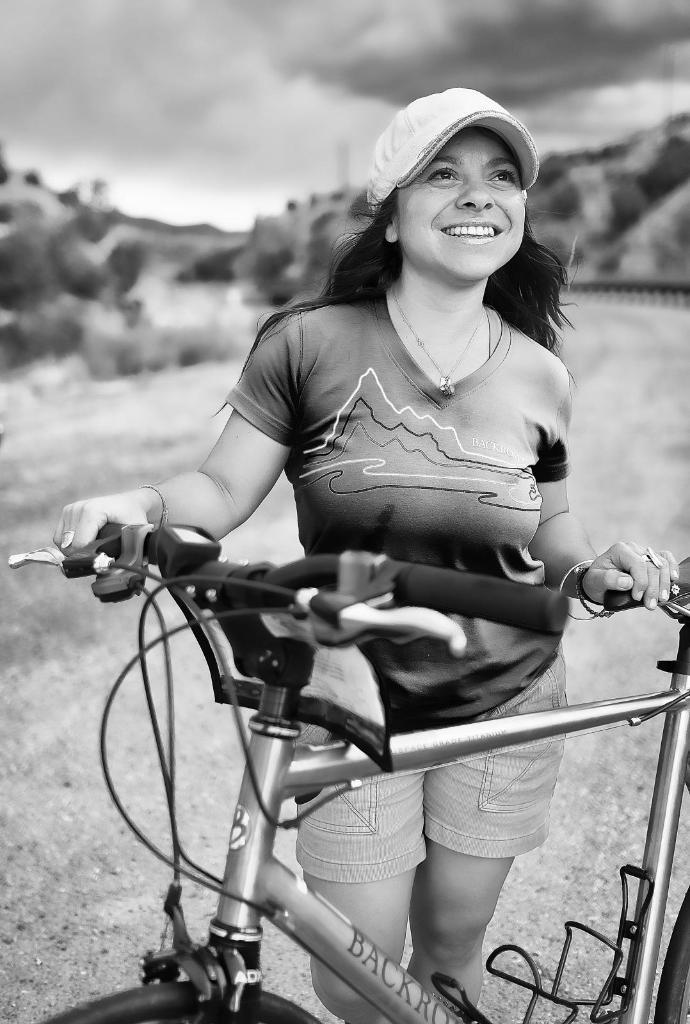What is the color scheme of the image? The image is black and white. Who is in the foreground of the image? There is a woman in the foreground of the image. What is the woman doing or holding in the image? The woman is with a bicycle. Can you describe the background of the image? The background of the image is blurred, and there are trees and a hill visible. What is the weather like in the image? The sky is cloudy in the image. Can you see the woman's toes in the image? There is no indication of the woman's toes in the image, as she is wearing shoes and the focus is on her and the bicycle. 